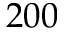<formula> <loc_0><loc_0><loc_500><loc_500>2 0 0</formula> 